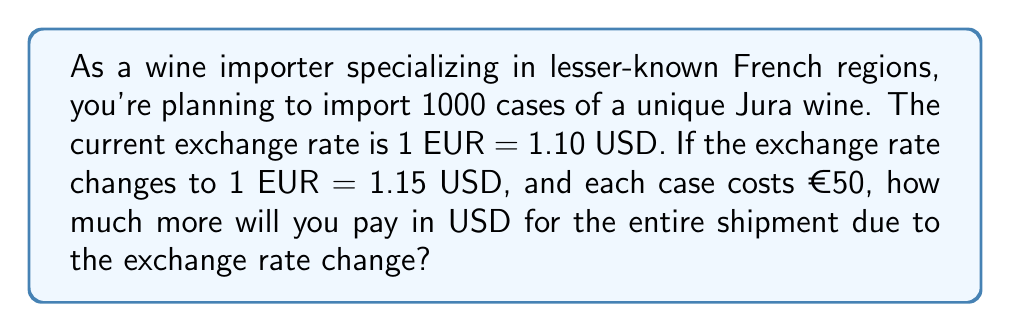Solve this math problem. Let's approach this problem step by step:

1) First, let's calculate the cost in EUR:
   $1000 \text{ cases} \times €50/\text{case} = €50,000$

2) Now, let's calculate the cost in USD at the initial exchange rate:
   $€50,000 \times 1.10 \text{ USD/EUR} = \$55,000$

3) Next, let's calculate the cost in USD at the new exchange rate:
   $€50,000 \times 1.15 \text{ USD/EUR} = \$57,500$

4) To find the difference, we subtract:
   $\$57,500 - \$55,000 = \$2,500$

The linear equation that represents this situation is:

$$ y = mx $$

Where:
$y$ is the cost in USD
$m$ is the exchange rate (USD/EUR)
$x$ is the cost in EUR

The change in $y$ when $m$ changes represents the additional cost due to the exchange rate change.
Answer: $2,500 USD 